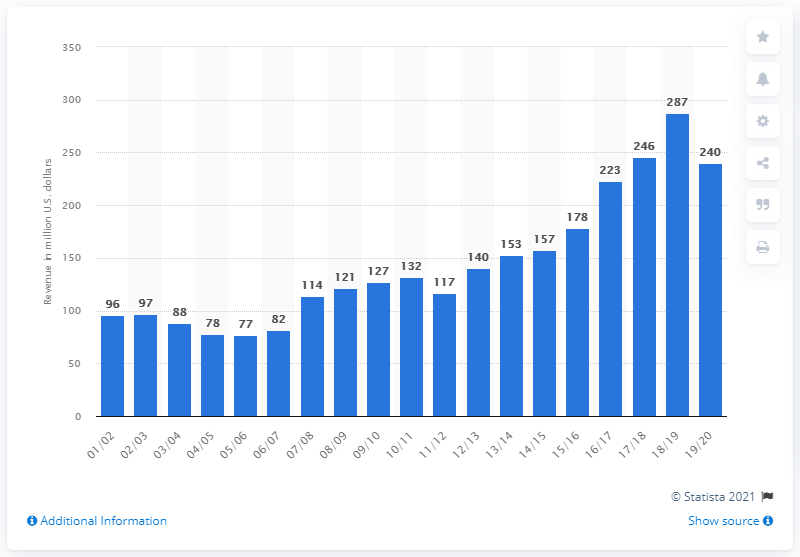Point out several critical features in this image. In the 2019/2020 season, the Portland Trail Blazers generated an estimated revenue of approximately 240 million dollars. 